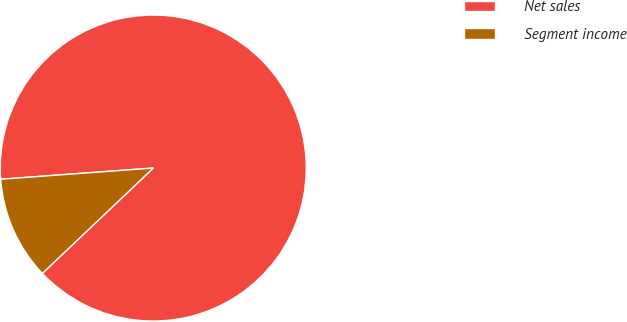Convert chart to OTSL. <chart><loc_0><loc_0><loc_500><loc_500><pie_chart><fcel>Net sales<fcel>Segment income<nl><fcel>89.08%<fcel>10.92%<nl></chart> 